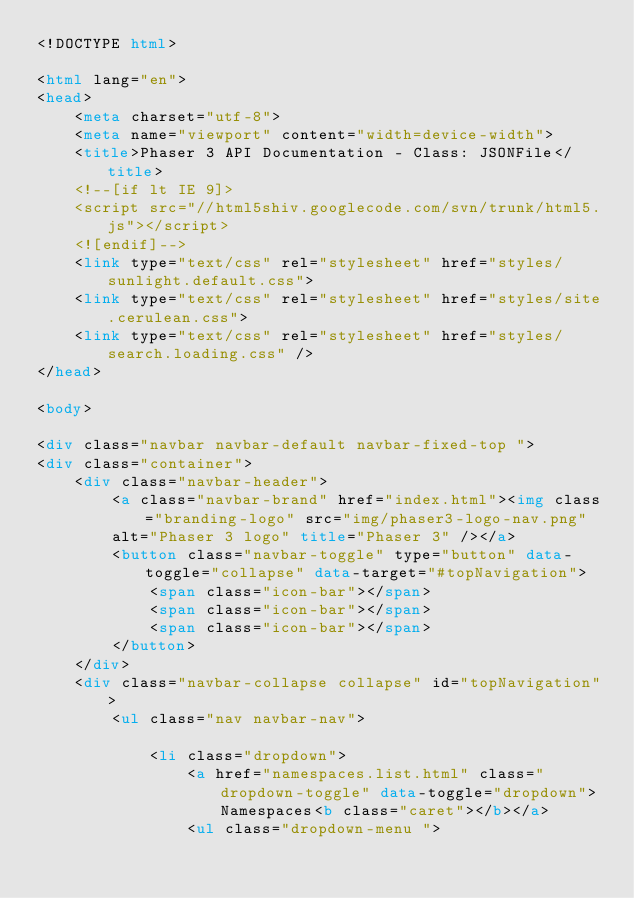Convert code to text. <code><loc_0><loc_0><loc_500><loc_500><_HTML_><!DOCTYPE html>

<html lang="en">
<head>
	<meta charset="utf-8">
	<meta name="viewport" content="width=device-width">
	<title>Phaser 3 API Documentation - Class: JSONFile</title>
	<!--[if lt IE 9]>
	<script src="//html5shiv.googlecode.com/svn/trunk/html5.js"></script>
	<![endif]-->
	<link type="text/css" rel="stylesheet" href="styles/sunlight.default.css">
	<link type="text/css" rel="stylesheet" href="styles/site.cerulean.css">
	<link type="text/css" rel="stylesheet" href="styles/search.loading.css" />
</head>

<body>

<div class="navbar navbar-default navbar-fixed-top ">
<div class="container">
	<div class="navbar-header">
		<a class="navbar-brand" href="index.html"><img class="branding-logo" src="img/phaser3-logo-nav.png"
		alt="Phaser 3 logo" title="Phaser 3" /></a>
		<button class="navbar-toggle" type="button" data-toggle="collapse" data-target="#topNavigation">
			<span class="icon-bar"></span>
			<span class="icon-bar"></span>
			<span class="icon-bar"></span>
        </button>
	</div>
	<div class="navbar-collapse collapse" id="topNavigation">
		<ul class="nav navbar-nav">
			
			<li class="dropdown">
				<a href="namespaces.list.html" class="dropdown-toggle" data-toggle="dropdown">Namespaces<b class="caret"></b></a>
				<ul class="dropdown-menu "></code> 